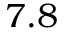Convert formula to latex. <formula><loc_0><loc_0><loc_500><loc_500>7 . 8</formula> 